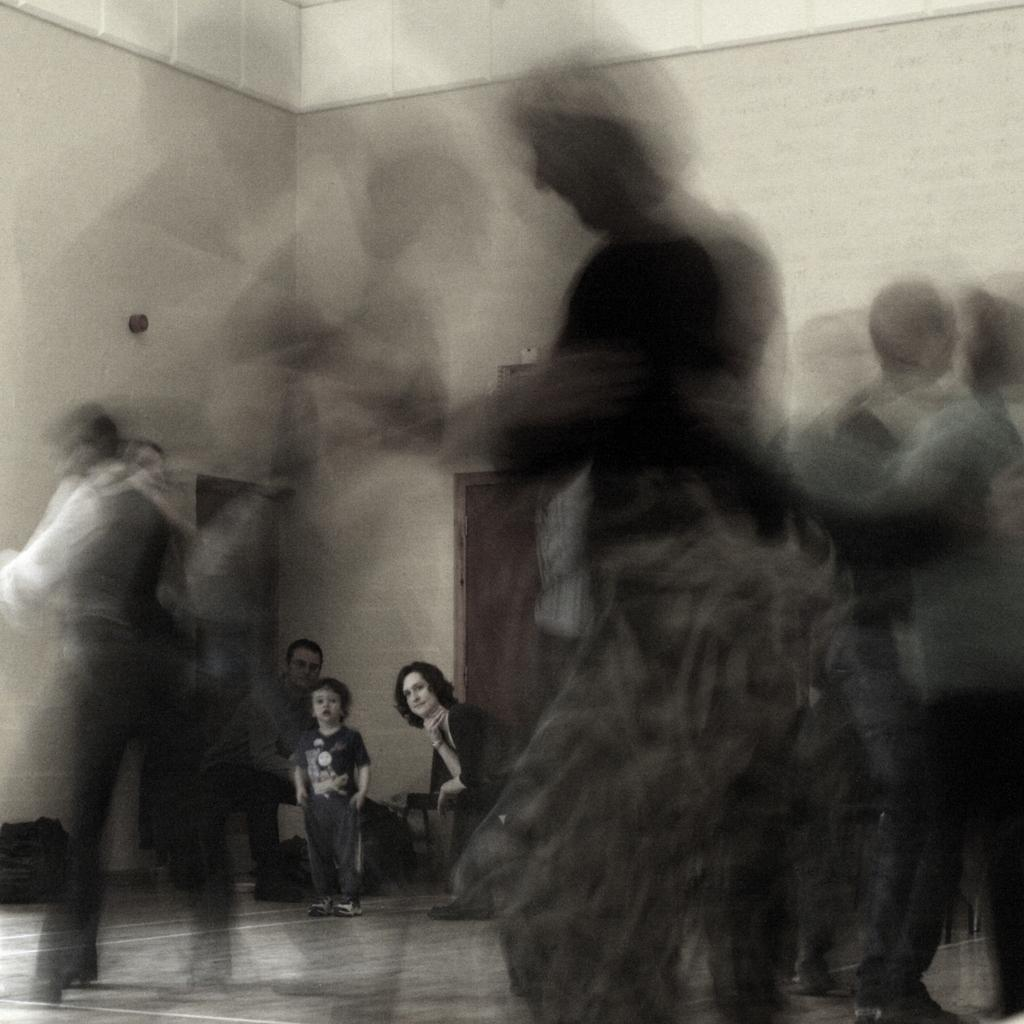Who can be seen in the front of the image? There are people in the front of the image, specifically two persons and a kid. Can you describe the individuals in the front of the image? There are two adults and a kid in the front of the image. What is visible in the background of the image? There is a wall and doors in the background of the image. What type of legal advice is the lawyer providing to the flesh in the image? There is no lawyer or flesh present in the image. 